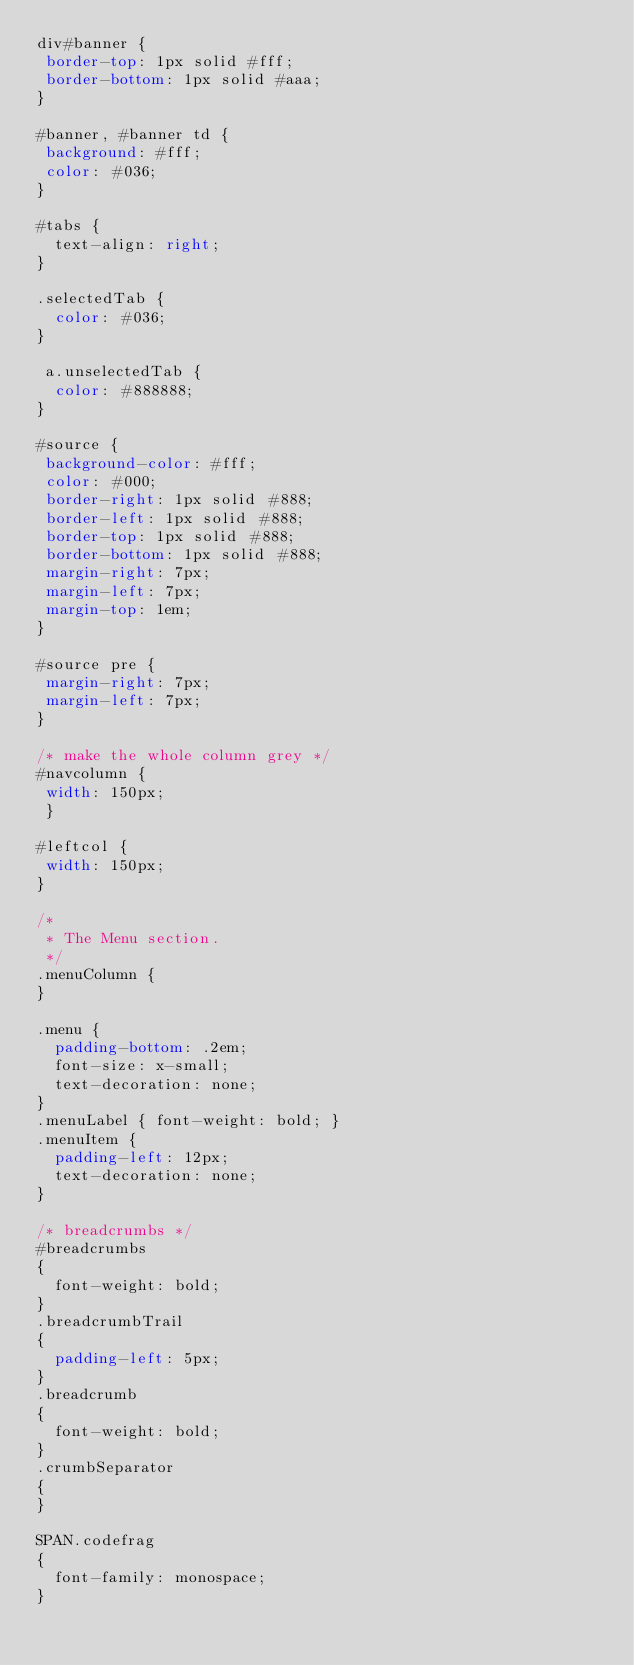<code> <loc_0><loc_0><loc_500><loc_500><_CSS_>div#banner {
 border-top: 1px solid #fff;
 border-bottom: 1px solid #aaa;
}

#banner, #banner td {
 background: #fff;
 color: #036;
}

#tabs {
  text-align: right;
}

.selectedTab {
  color: #036;	
}

 a.unselectedTab {
  color: #888888;	
}

#source {
 background-color: #fff;
 color: #000;
 border-right: 1px solid #888;
 border-left: 1px solid #888;
 border-top: 1px solid #888;
 border-bottom: 1px solid #888;
 margin-right: 7px;
 margin-left: 7px;
 margin-top: 1em;
}

#source pre {
 margin-right: 7px;
 margin-left: 7px;
}

/* make the whole column grey */
#navcolumn {
 width: 150px;
 }

#leftcol {
 width: 150px;
}

/*
 * The Menu section.
 */
.menuColumn {
}

.menu {
  padding-bottom: .2em;
  font-size: x-small;
  text-decoration: none;
}
.menuLabel { font-weight: bold; }
.menuItem {
  padding-left: 12px;
  text-decoration: none;
}

/* breadcrumbs */
#breadcrumbs
{
	font-weight: bold;
}
.breadcrumbTrail
{
	padding-left: 5px;
}
.breadcrumb
{
	font-weight: bold;
}
.crumbSeparator
{
}

SPAN.codefrag
{
  font-family: monospace;
}
</code> 